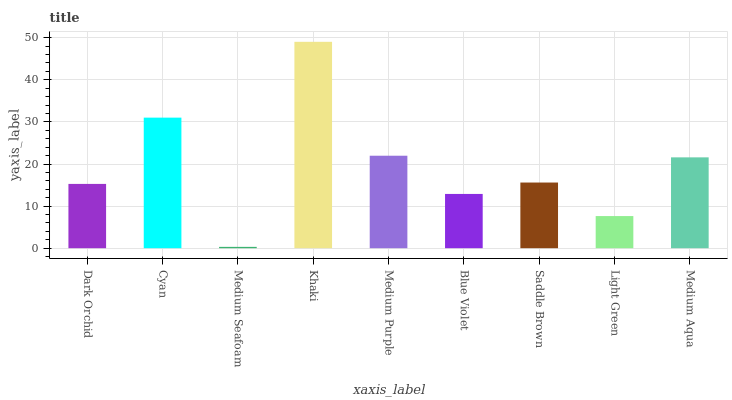Is Medium Seafoam the minimum?
Answer yes or no. Yes. Is Khaki the maximum?
Answer yes or no. Yes. Is Cyan the minimum?
Answer yes or no. No. Is Cyan the maximum?
Answer yes or no. No. Is Cyan greater than Dark Orchid?
Answer yes or no. Yes. Is Dark Orchid less than Cyan?
Answer yes or no. Yes. Is Dark Orchid greater than Cyan?
Answer yes or no. No. Is Cyan less than Dark Orchid?
Answer yes or no. No. Is Saddle Brown the high median?
Answer yes or no. Yes. Is Saddle Brown the low median?
Answer yes or no. Yes. Is Dark Orchid the high median?
Answer yes or no. No. Is Khaki the low median?
Answer yes or no. No. 